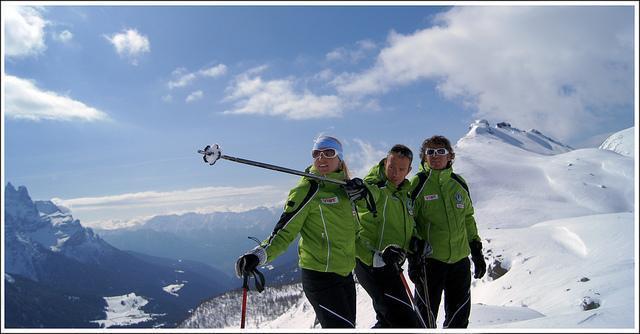How many people are wearing hats?
Give a very brief answer. 1. How many people are in the photo?
Give a very brief answer. 3. How many elephants are facing the camera?
Give a very brief answer. 0. 